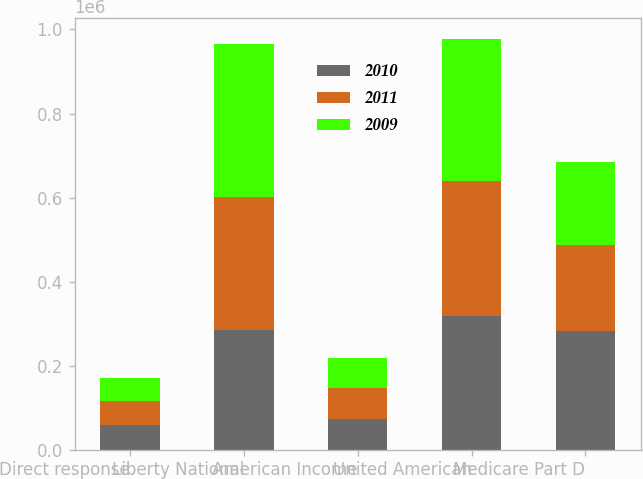<chart> <loc_0><loc_0><loc_500><loc_500><stacked_bar_chart><ecel><fcel>Direct response<fcel>Liberty National<fcel>American Income<fcel>United American<fcel>Medicare Part D<nl><fcel>2010<fcel>58512<fcel>284204<fcel>72991<fcel>317699<fcel>282987<nl><fcel>2011<fcel>57014<fcel>316839<fcel>74049<fcel>322383<fcel>203340<nl><fcel>2009<fcel>55108<fcel>365027<fcel>71836<fcel>337270<fcel>197319<nl></chart> 